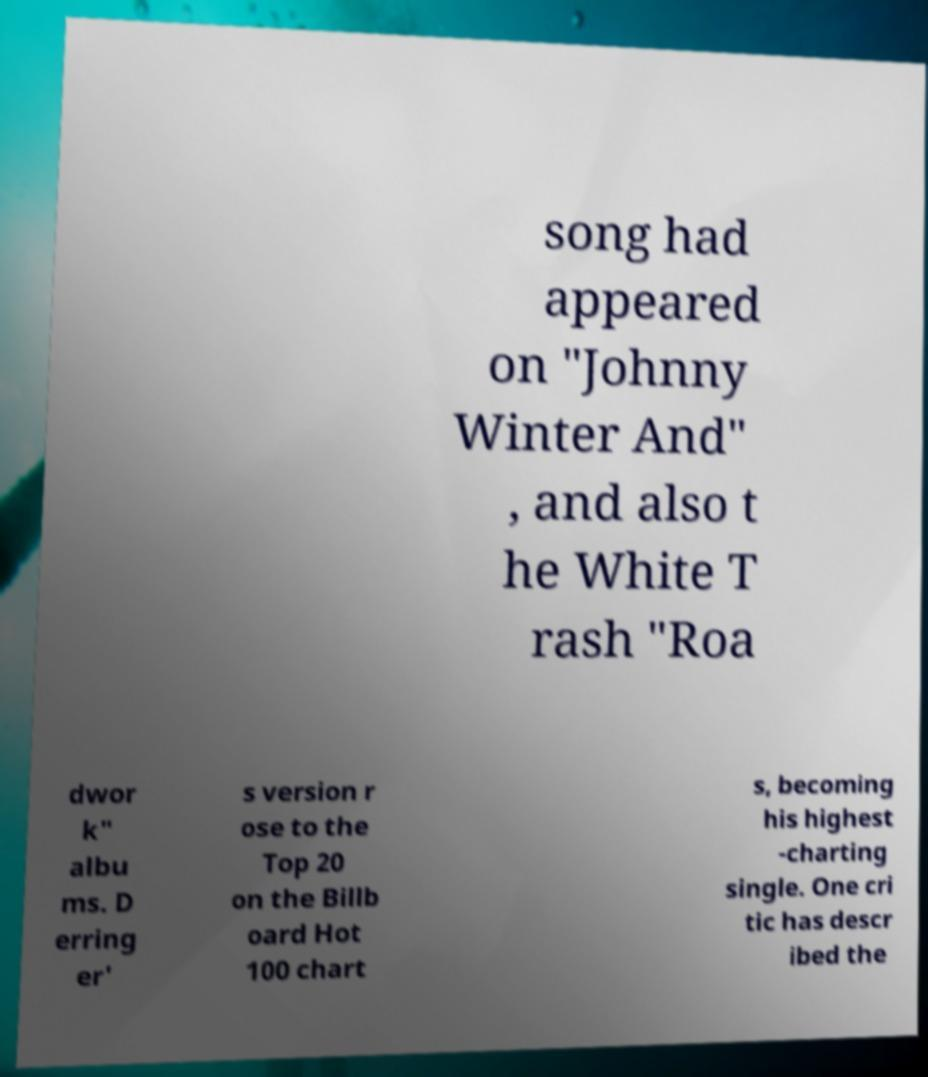For documentation purposes, I need the text within this image transcribed. Could you provide that? song had appeared on "Johnny Winter And" , and also t he White T rash "Roa dwor k" albu ms. D erring er' s version r ose to the Top 20 on the Billb oard Hot 100 chart s, becoming his highest -charting single. One cri tic has descr ibed the 